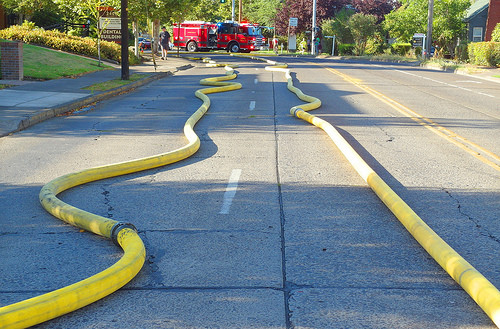<image>
Is the fire truck on the hose? No. The fire truck is not positioned on the hose. They may be near each other, but the fire truck is not supported by or resting on top of the hose. 